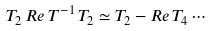Convert formula to latex. <formula><loc_0><loc_0><loc_500><loc_500>T _ { 2 } \, R e \, T ^ { - 1 } \, T _ { 2 } \simeq T _ { 2 } - R e \, T _ { 4 } \cdots</formula> 